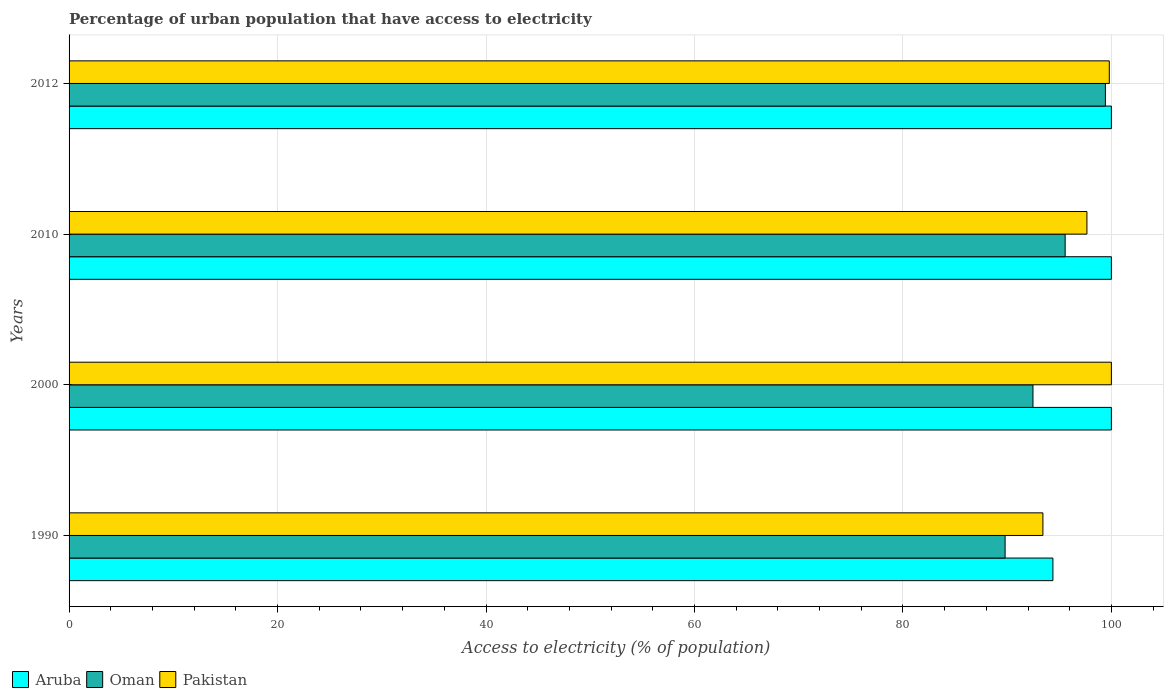How many groups of bars are there?
Offer a very short reply. 4. Are the number of bars per tick equal to the number of legend labels?
Keep it short and to the point. Yes. Are the number of bars on each tick of the Y-axis equal?
Give a very brief answer. Yes. How many bars are there on the 3rd tick from the top?
Keep it short and to the point. 3. How many bars are there on the 4th tick from the bottom?
Keep it short and to the point. 3. What is the label of the 3rd group of bars from the top?
Provide a succinct answer. 2000. In how many cases, is the number of bars for a given year not equal to the number of legend labels?
Give a very brief answer. 0. What is the percentage of urban population that have access to electricity in Oman in 2000?
Your answer should be compact. 92.48. Across all years, what is the minimum percentage of urban population that have access to electricity in Aruba?
Offer a very short reply. 94.39. What is the total percentage of urban population that have access to electricity in Aruba in the graph?
Provide a succinct answer. 394.39. What is the difference between the percentage of urban population that have access to electricity in Oman in 2000 and that in 2010?
Offer a terse response. -3.09. What is the difference between the percentage of urban population that have access to electricity in Pakistan in 1990 and the percentage of urban population that have access to electricity in Aruba in 2000?
Your answer should be very brief. -6.57. What is the average percentage of urban population that have access to electricity in Oman per year?
Make the answer very short. 94.32. In the year 1990, what is the difference between the percentage of urban population that have access to electricity in Aruba and percentage of urban population that have access to electricity in Pakistan?
Offer a very short reply. 0.96. In how many years, is the percentage of urban population that have access to electricity in Aruba greater than 36 %?
Offer a terse response. 4. What is the ratio of the percentage of urban population that have access to electricity in Pakistan in 1990 to that in 2010?
Provide a succinct answer. 0.96. What is the difference between the highest and the lowest percentage of urban population that have access to electricity in Pakistan?
Keep it short and to the point. 6.57. Is the sum of the percentage of urban population that have access to electricity in Pakistan in 1990 and 2010 greater than the maximum percentage of urban population that have access to electricity in Aruba across all years?
Keep it short and to the point. Yes. What does the 2nd bar from the bottom in 2010 represents?
Your answer should be compact. Oman. Are all the bars in the graph horizontal?
Give a very brief answer. Yes. How many years are there in the graph?
Make the answer very short. 4. What is the difference between two consecutive major ticks on the X-axis?
Provide a short and direct response. 20. Does the graph contain any zero values?
Ensure brevity in your answer.  No. Where does the legend appear in the graph?
Your answer should be very brief. Bottom left. How many legend labels are there?
Give a very brief answer. 3. How are the legend labels stacked?
Your response must be concise. Horizontal. What is the title of the graph?
Provide a short and direct response. Percentage of urban population that have access to electricity. What is the label or title of the X-axis?
Keep it short and to the point. Access to electricity (% of population). What is the Access to electricity (% of population) in Aruba in 1990?
Keep it short and to the point. 94.39. What is the Access to electricity (% of population) of Oman in 1990?
Offer a very short reply. 89.8. What is the Access to electricity (% of population) of Pakistan in 1990?
Offer a terse response. 93.43. What is the Access to electricity (% of population) in Oman in 2000?
Your response must be concise. 92.48. What is the Access to electricity (% of population) of Pakistan in 2000?
Give a very brief answer. 100. What is the Access to electricity (% of population) of Oman in 2010?
Your answer should be very brief. 95.57. What is the Access to electricity (% of population) in Pakistan in 2010?
Your answer should be very brief. 97.65. What is the Access to electricity (% of population) of Oman in 2012?
Your answer should be very brief. 99.43. What is the Access to electricity (% of population) in Pakistan in 2012?
Provide a short and direct response. 99.8. Across all years, what is the maximum Access to electricity (% of population) in Oman?
Offer a terse response. 99.43. Across all years, what is the maximum Access to electricity (% of population) of Pakistan?
Give a very brief answer. 100. Across all years, what is the minimum Access to electricity (% of population) of Aruba?
Your answer should be very brief. 94.39. Across all years, what is the minimum Access to electricity (% of population) in Oman?
Make the answer very short. 89.8. Across all years, what is the minimum Access to electricity (% of population) of Pakistan?
Provide a short and direct response. 93.43. What is the total Access to electricity (% of population) of Aruba in the graph?
Ensure brevity in your answer.  394.39. What is the total Access to electricity (% of population) in Oman in the graph?
Make the answer very short. 377.27. What is the total Access to electricity (% of population) of Pakistan in the graph?
Offer a very short reply. 390.89. What is the difference between the Access to electricity (% of population) of Aruba in 1990 and that in 2000?
Give a very brief answer. -5.61. What is the difference between the Access to electricity (% of population) in Oman in 1990 and that in 2000?
Provide a succinct answer. -2.67. What is the difference between the Access to electricity (% of population) of Pakistan in 1990 and that in 2000?
Make the answer very short. -6.57. What is the difference between the Access to electricity (% of population) of Aruba in 1990 and that in 2010?
Keep it short and to the point. -5.61. What is the difference between the Access to electricity (% of population) of Oman in 1990 and that in 2010?
Offer a terse response. -5.76. What is the difference between the Access to electricity (% of population) in Pakistan in 1990 and that in 2010?
Keep it short and to the point. -4.22. What is the difference between the Access to electricity (% of population) in Aruba in 1990 and that in 2012?
Keep it short and to the point. -5.61. What is the difference between the Access to electricity (% of population) in Oman in 1990 and that in 2012?
Provide a succinct answer. -9.62. What is the difference between the Access to electricity (% of population) of Pakistan in 1990 and that in 2012?
Your answer should be compact. -6.37. What is the difference between the Access to electricity (% of population) in Oman in 2000 and that in 2010?
Keep it short and to the point. -3.09. What is the difference between the Access to electricity (% of population) in Pakistan in 2000 and that in 2010?
Keep it short and to the point. 2.35. What is the difference between the Access to electricity (% of population) in Aruba in 2000 and that in 2012?
Your answer should be very brief. 0. What is the difference between the Access to electricity (% of population) in Oman in 2000 and that in 2012?
Ensure brevity in your answer.  -6.95. What is the difference between the Access to electricity (% of population) of Oman in 2010 and that in 2012?
Make the answer very short. -3.86. What is the difference between the Access to electricity (% of population) in Pakistan in 2010 and that in 2012?
Your answer should be very brief. -2.15. What is the difference between the Access to electricity (% of population) in Aruba in 1990 and the Access to electricity (% of population) in Oman in 2000?
Offer a terse response. 1.91. What is the difference between the Access to electricity (% of population) of Aruba in 1990 and the Access to electricity (% of population) of Pakistan in 2000?
Make the answer very short. -5.61. What is the difference between the Access to electricity (% of population) of Oman in 1990 and the Access to electricity (% of population) of Pakistan in 2000?
Provide a succinct answer. -10.2. What is the difference between the Access to electricity (% of population) in Aruba in 1990 and the Access to electricity (% of population) in Oman in 2010?
Your answer should be compact. -1.18. What is the difference between the Access to electricity (% of population) of Aruba in 1990 and the Access to electricity (% of population) of Pakistan in 2010?
Offer a very short reply. -3.26. What is the difference between the Access to electricity (% of population) in Oman in 1990 and the Access to electricity (% of population) in Pakistan in 2010?
Offer a very short reply. -7.85. What is the difference between the Access to electricity (% of population) in Aruba in 1990 and the Access to electricity (% of population) in Oman in 2012?
Offer a terse response. -5.04. What is the difference between the Access to electricity (% of population) in Aruba in 1990 and the Access to electricity (% of population) in Pakistan in 2012?
Provide a succinct answer. -5.41. What is the difference between the Access to electricity (% of population) of Oman in 1990 and the Access to electricity (% of population) of Pakistan in 2012?
Provide a succinct answer. -10. What is the difference between the Access to electricity (% of population) in Aruba in 2000 and the Access to electricity (% of population) in Oman in 2010?
Keep it short and to the point. 4.43. What is the difference between the Access to electricity (% of population) in Aruba in 2000 and the Access to electricity (% of population) in Pakistan in 2010?
Provide a short and direct response. 2.35. What is the difference between the Access to electricity (% of population) in Oman in 2000 and the Access to electricity (% of population) in Pakistan in 2010?
Give a very brief answer. -5.18. What is the difference between the Access to electricity (% of population) in Aruba in 2000 and the Access to electricity (% of population) in Oman in 2012?
Keep it short and to the point. 0.57. What is the difference between the Access to electricity (% of population) of Aruba in 2000 and the Access to electricity (% of population) of Pakistan in 2012?
Offer a very short reply. 0.2. What is the difference between the Access to electricity (% of population) of Oman in 2000 and the Access to electricity (% of population) of Pakistan in 2012?
Provide a succinct answer. -7.32. What is the difference between the Access to electricity (% of population) of Aruba in 2010 and the Access to electricity (% of population) of Oman in 2012?
Your response must be concise. 0.57. What is the difference between the Access to electricity (% of population) of Aruba in 2010 and the Access to electricity (% of population) of Pakistan in 2012?
Ensure brevity in your answer.  0.2. What is the difference between the Access to electricity (% of population) of Oman in 2010 and the Access to electricity (% of population) of Pakistan in 2012?
Your answer should be compact. -4.23. What is the average Access to electricity (% of population) in Aruba per year?
Provide a short and direct response. 98.6. What is the average Access to electricity (% of population) of Oman per year?
Ensure brevity in your answer.  94.32. What is the average Access to electricity (% of population) of Pakistan per year?
Ensure brevity in your answer.  97.72. In the year 1990, what is the difference between the Access to electricity (% of population) in Aruba and Access to electricity (% of population) in Oman?
Offer a very short reply. 4.59. In the year 1990, what is the difference between the Access to electricity (% of population) of Aruba and Access to electricity (% of population) of Pakistan?
Your answer should be very brief. 0.96. In the year 1990, what is the difference between the Access to electricity (% of population) in Oman and Access to electricity (% of population) in Pakistan?
Ensure brevity in your answer.  -3.63. In the year 2000, what is the difference between the Access to electricity (% of population) of Aruba and Access to electricity (% of population) of Oman?
Ensure brevity in your answer.  7.52. In the year 2000, what is the difference between the Access to electricity (% of population) in Oman and Access to electricity (% of population) in Pakistan?
Your answer should be very brief. -7.52. In the year 2010, what is the difference between the Access to electricity (% of population) in Aruba and Access to electricity (% of population) in Oman?
Ensure brevity in your answer.  4.43. In the year 2010, what is the difference between the Access to electricity (% of population) in Aruba and Access to electricity (% of population) in Pakistan?
Your answer should be very brief. 2.35. In the year 2010, what is the difference between the Access to electricity (% of population) of Oman and Access to electricity (% of population) of Pakistan?
Keep it short and to the point. -2.09. In the year 2012, what is the difference between the Access to electricity (% of population) in Aruba and Access to electricity (% of population) in Oman?
Provide a succinct answer. 0.57. In the year 2012, what is the difference between the Access to electricity (% of population) of Aruba and Access to electricity (% of population) of Pakistan?
Provide a short and direct response. 0.2. In the year 2012, what is the difference between the Access to electricity (% of population) of Oman and Access to electricity (% of population) of Pakistan?
Offer a very short reply. -0.37. What is the ratio of the Access to electricity (% of population) of Aruba in 1990 to that in 2000?
Your answer should be compact. 0.94. What is the ratio of the Access to electricity (% of population) of Oman in 1990 to that in 2000?
Make the answer very short. 0.97. What is the ratio of the Access to electricity (% of population) in Pakistan in 1990 to that in 2000?
Provide a succinct answer. 0.93. What is the ratio of the Access to electricity (% of population) in Aruba in 1990 to that in 2010?
Offer a terse response. 0.94. What is the ratio of the Access to electricity (% of population) in Oman in 1990 to that in 2010?
Ensure brevity in your answer.  0.94. What is the ratio of the Access to electricity (% of population) of Pakistan in 1990 to that in 2010?
Your answer should be compact. 0.96. What is the ratio of the Access to electricity (% of population) of Aruba in 1990 to that in 2012?
Keep it short and to the point. 0.94. What is the ratio of the Access to electricity (% of population) in Oman in 1990 to that in 2012?
Provide a succinct answer. 0.9. What is the ratio of the Access to electricity (% of population) of Pakistan in 1990 to that in 2012?
Offer a very short reply. 0.94. What is the ratio of the Access to electricity (% of population) in Oman in 2000 to that in 2010?
Provide a succinct answer. 0.97. What is the ratio of the Access to electricity (% of population) of Pakistan in 2000 to that in 2010?
Your response must be concise. 1.02. What is the ratio of the Access to electricity (% of population) of Aruba in 2000 to that in 2012?
Offer a very short reply. 1. What is the ratio of the Access to electricity (% of population) of Oman in 2000 to that in 2012?
Keep it short and to the point. 0.93. What is the ratio of the Access to electricity (% of population) in Oman in 2010 to that in 2012?
Your response must be concise. 0.96. What is the ratio of the Access to electricity (% of population) of Pakistan in 2010 to that in 2012?
Provide a short and direct response. 0.98. What is the difference between the highest and the second highest Access to electricity (% of population) of Aruba?
Your answer should be very brief. 0. What is the difference between the highest and the second highest Access to electricity (% of population) in Oman?
Your answer should be very brief. 3.86. What is the difference between the highest and the second highest Access to electricity (% of population) of Pakistan?
Make the answer very short. 0.2. What is the difference between the highest and the lowest Access to electricity (% of population) of Aruba?
Offer a terse response. 5.61. What is the difference between the highest and the lowest Access to electricity (% of population) in Oman?
Give a very brief answer. 9.62. What is the difference between the highest and the lowest Access to electricity (% of population) in Pakistan?
Make the answer very short. 6.57. 